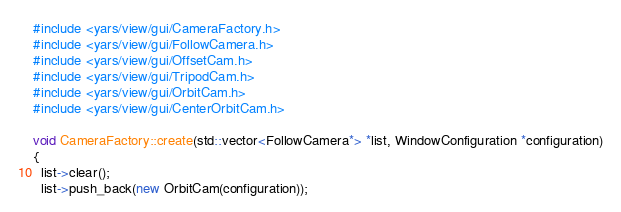Convert code to text. <code><loc_0><loc_0><loc_500><loc_500><_C++_>#include <yars/view/gui/CameraFactory.h>
#include <yars/view/gui/FollowCamera.h>
#include <yars/view/gui/OffsetCam.h>
#include <yars/view/gui/TripodCam.h>
#include <yars/view/gui/OrbitCam.h>
#include <yars/view/gui/CenterOrbitCam.h>

void CameraFactory::create(std::vector<FollowCamera*> *list, WindowConfiguration *configuration)
{
  list->clear();
  list->push_back(new OrbitCam(configuration));</code> 